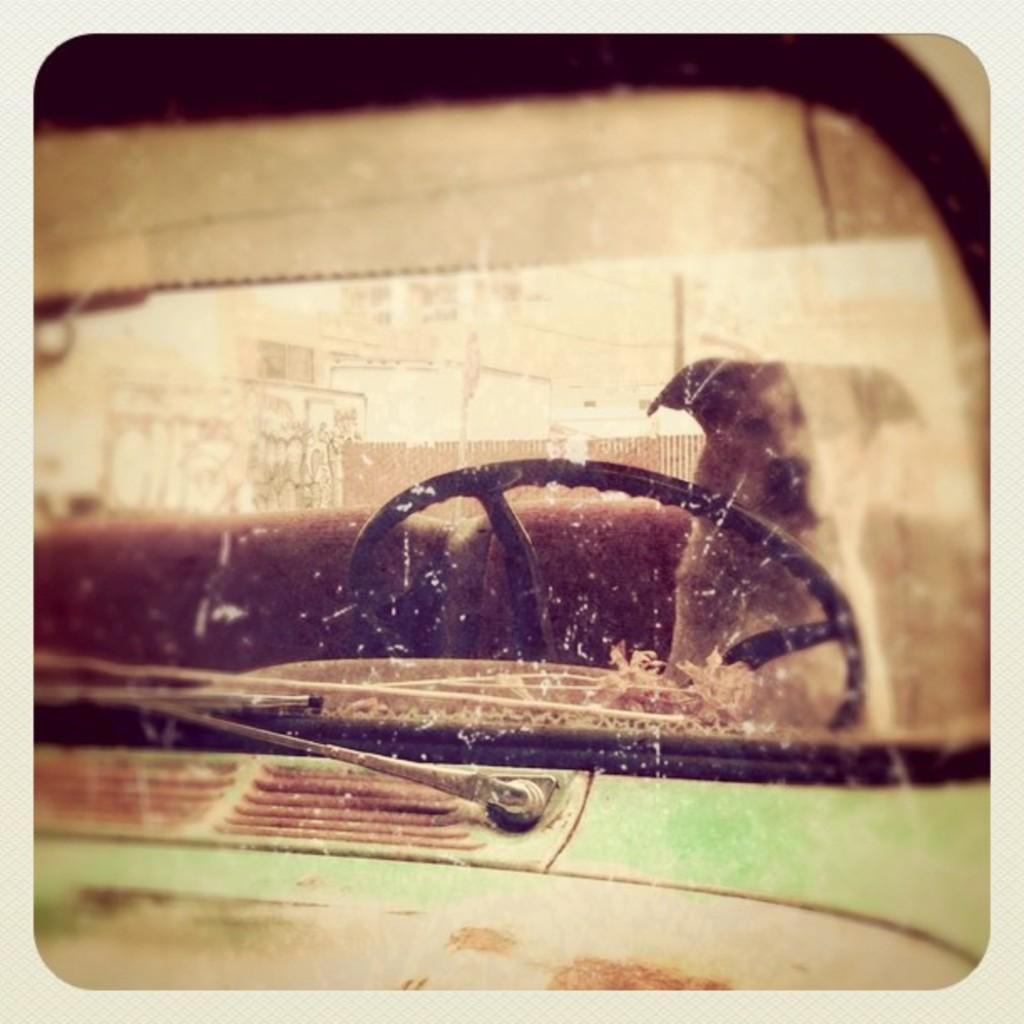Could you give a brief overview of what you see in this image? In this image we can see a dog in the motor vehicle. In the background we can see buildings and an iron grill. 